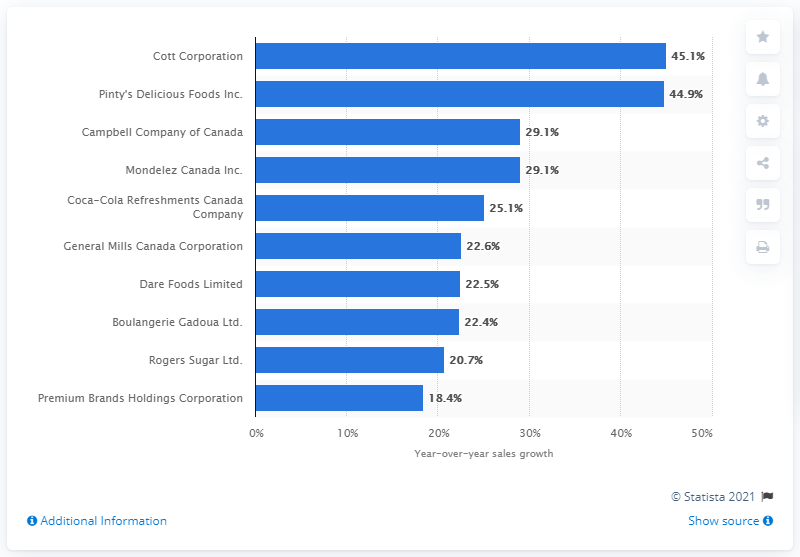Which company comes second after Cott Corporation in terms of sales growth? Pinty's Delicious Foods Inc. closely follows Cott Corporation, with a sales growth figure of 44.9%, making it a competitive year for these leading companies. 